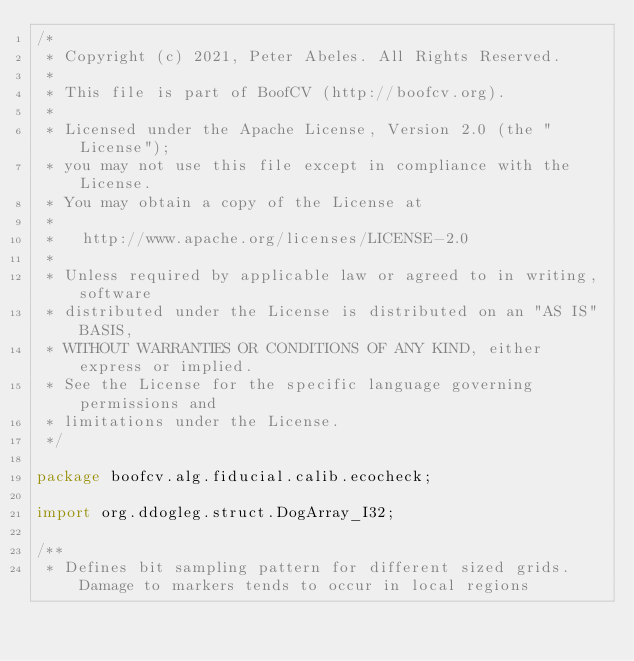<code> <loc_0><loc_0><loc_500><loc_500><_Java_>/*
 * Copyright (c) 2021, Peter Abeles. All Rights Reserved.
 *
 * This file is part of BoofCV (http://boofcv.org).
 *
 * Licensed under the Apache License, Version 2.0 (the "License");
 * you may not use this file except in compliance with the License.
 * You may obtain a copy of the License at
 *
 *   http://www.apache.org/licenses/LICENSE-2.0
 *
 * Unless required by applicable law or agreed to in writing, software
 * distributed under the License is distributed on an "AS IS" BASIS,
 * WITHOUT WARRANTIES OR CONDITIONS OF ANY KIND, either express or implied.
 * See the License for the specific language governing permissions and
 * limitations under the License.
 */

package boofcv.alg.fiducial.calib.ecocheck;

import org.ddogleg.struct.DogArray_I32;

/**
 * Defines bit sampling pattern for different sized grids. Damage to markers tends to occur in local regions</code> 